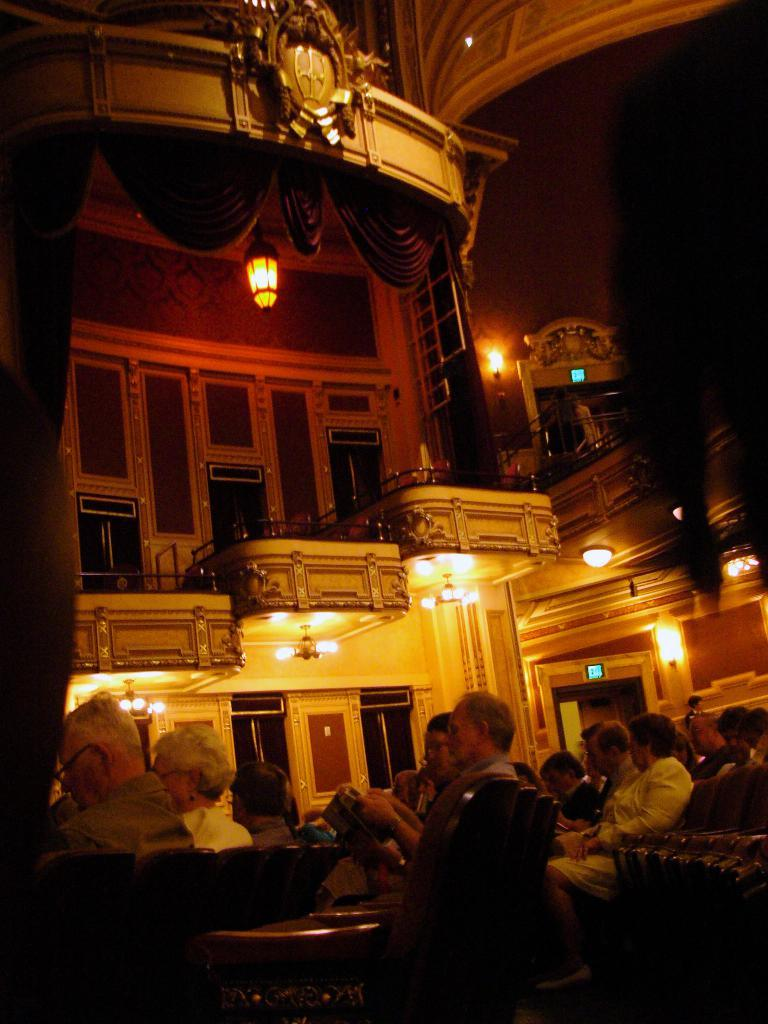How many people are in the image? There is a group of people in the image. What are the people doing in the image? The people are seated. What can be seen in the background of the image? There are lights, metal rods, and curtains in the background of the image. What type of pencil is the stranger using to draw in the image? There is no stranger or pencil present in the image. What effect does the pencil have on the people in the image? There is no pencil or effect on the people in the image, as there is no pencil or stranger present. 